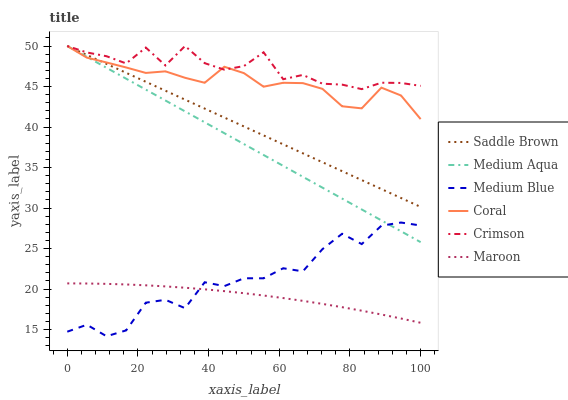Does Maroon have the minimum area under the curve?
Answer yes or no. Yes. Does Medium Blue have the minimum area under the curve?
Answer yes or no. No. Does Medium Blue have the maximum area under the curve?
Answer yes or no. No. Is Maroon the smoothest?
Answer yes or no. No. Is Maroon the roughest?
Answer yes or no. No. Does Maroon have the lowest value?
Answer yes or no. No. Does Medium Blue have the highest value?
Answer yes or no. No. Is Maroon less than Coral?
Answer yes or no. Yes. Is Saddle Brown greater than Medium Blue?
Answer yes or no. Yes. Does Maroon intersect Coral?
Answer yes or no. No. 